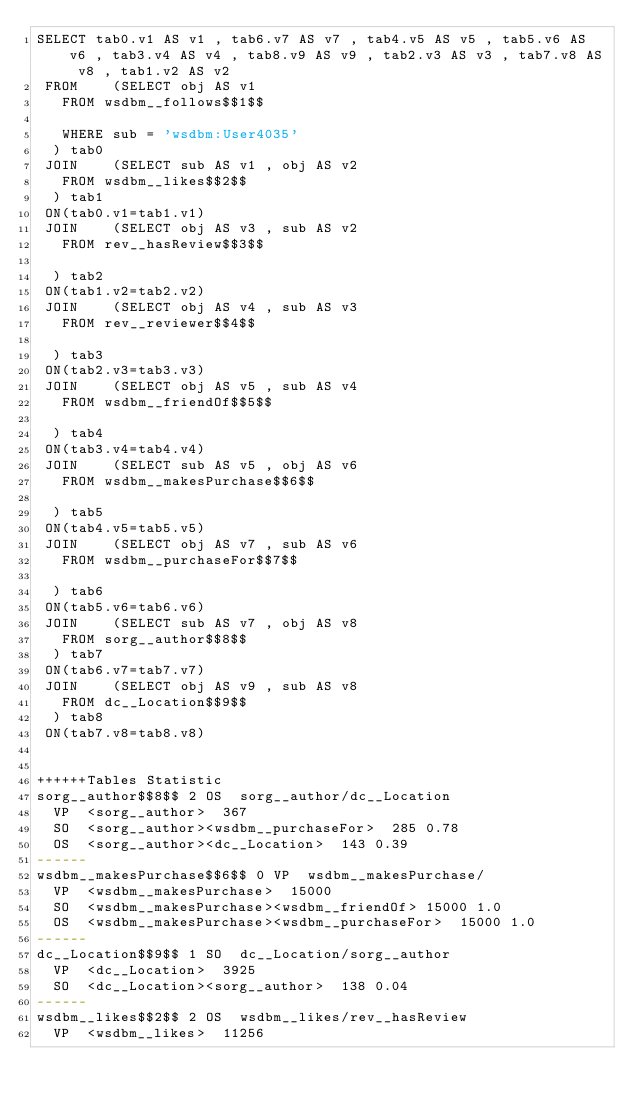<code> <loc_0><loc_0><loc_500><loc_500><_SQL_>SELECT tab0.v1 AS v1 , tab6.v7 AS v7 , tab4.v5 AS v5 , tab5.v6 AS v6 , tab3.v4 AS v4 , tab8.v9 AS v9 , tab2.v3 AS v3 , tab7.v8 AS v8 , tab1.v2 AS v2 
 FROM    (SELECT obj AS v1 
	 FROM wsdbm__follows$$1$$
	 
	 WHERE sub = 'wsdbm:User4035'
	) tab0
 JOIN    (SELECT sub AS v1 , obj AS v2 
	 FROM wsdbm__likes$$2$$
	) tab1
 ON(tab0.v1=tab1.v1)
 JOIN    (SELECT obj AS v3 , sub AS v2 
	 FROM rev__hasReview$$3$$
	
	) tab2
 ON(tab1.v2=tab2.v2)
 JOIN    (SELECT obj AS v4 , sub AS v3 
	 FROM rev__reviewer$$4$$
	
	) tab3
 ON(tab2.v3=tab3.v3)
 JOIN    (SELECT obj AS v5 , sub AS v4 
	 FROM wsdbm__friendOf$$5$$
	
	) tab4
 ON(tab3.v4=tab4.v4)
 JOIN    (SELECT sub AS v5 , obj AS v6 
	 FROM wsdbm__makesPurchase$$6$$
	
	) tab5
 ON(tab4.v5=tab5.v5)
 JOIN    (SELECT obj AS v7 , sub AS v6 
	 FROM wsdbm__purchaseFor$$7$$
	
	) tab6
 ON(tab5.v6=tab6.v6)
 JOIN    (SELECT sub AS v7 , obj AS v8 
	 FROM sorg__author$$8$$
	) tab7
 ON(tab6.v7=tab7.v7)
 JOIN    (SELECT obj AS v9 , sub AS v8 
	 FROM dc__Location$$9$$
	) tab8
 ON(tab7.v8=tab8.v8)


++++++Tables Statistic
sorg__author$$8$$	2	OS	sorg__author/dc__Location
	VP	<sorg__author>	367
	SO	<sorg__author><wsdbm__purchaseFor>	285	0.78
	OS	<sorg__author><dc__Location>	143	0.39
------
wsdbm__makesPurchase$$6$$	0	VP	wsdbm__makesPurchase/
	VP	<wsdbm__makesPurchase>	15000
	SO	<wsdbm__makesPurchase><wsdbm__friendOf>	15000	1.0
	OS	<wsdbm__makesPurchase><wsdbm__purchaseFor>	15000	1.0
------
dc__Location$$9$$	1	SO	dc__Location/sorg__author
	VP	<dc__Location>	3925
	SO	<dc__Location><sorg__author>	138	0.04
------
wsdbm__likes$$2$$	2	OS	wsdbm__likes/rev__hasReview
	VP	<wsdbm__likes>	11256</code> 